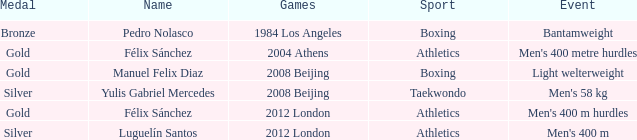What medal carried the name of manuel felix diaz? Gold. 